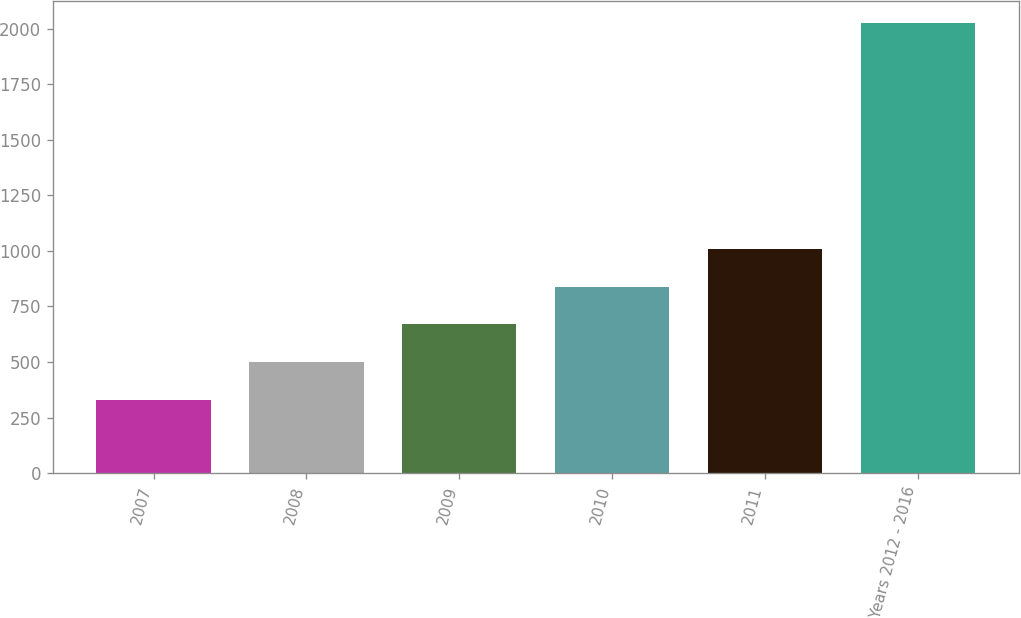Convert chart to OTSL. <chart><loc_0><loc_0><loc_500><loc_500><bar_chart><fcel>2007<fcel>2008<fcel>2009<fcel>2010<fcel>2011<fcel>Years 2012 - 2016<nl><fcel>331<fcel>500.4<fcel>669.8<fcel>839.2<fcel>1008.6<fcel>2025<nl></chart> 